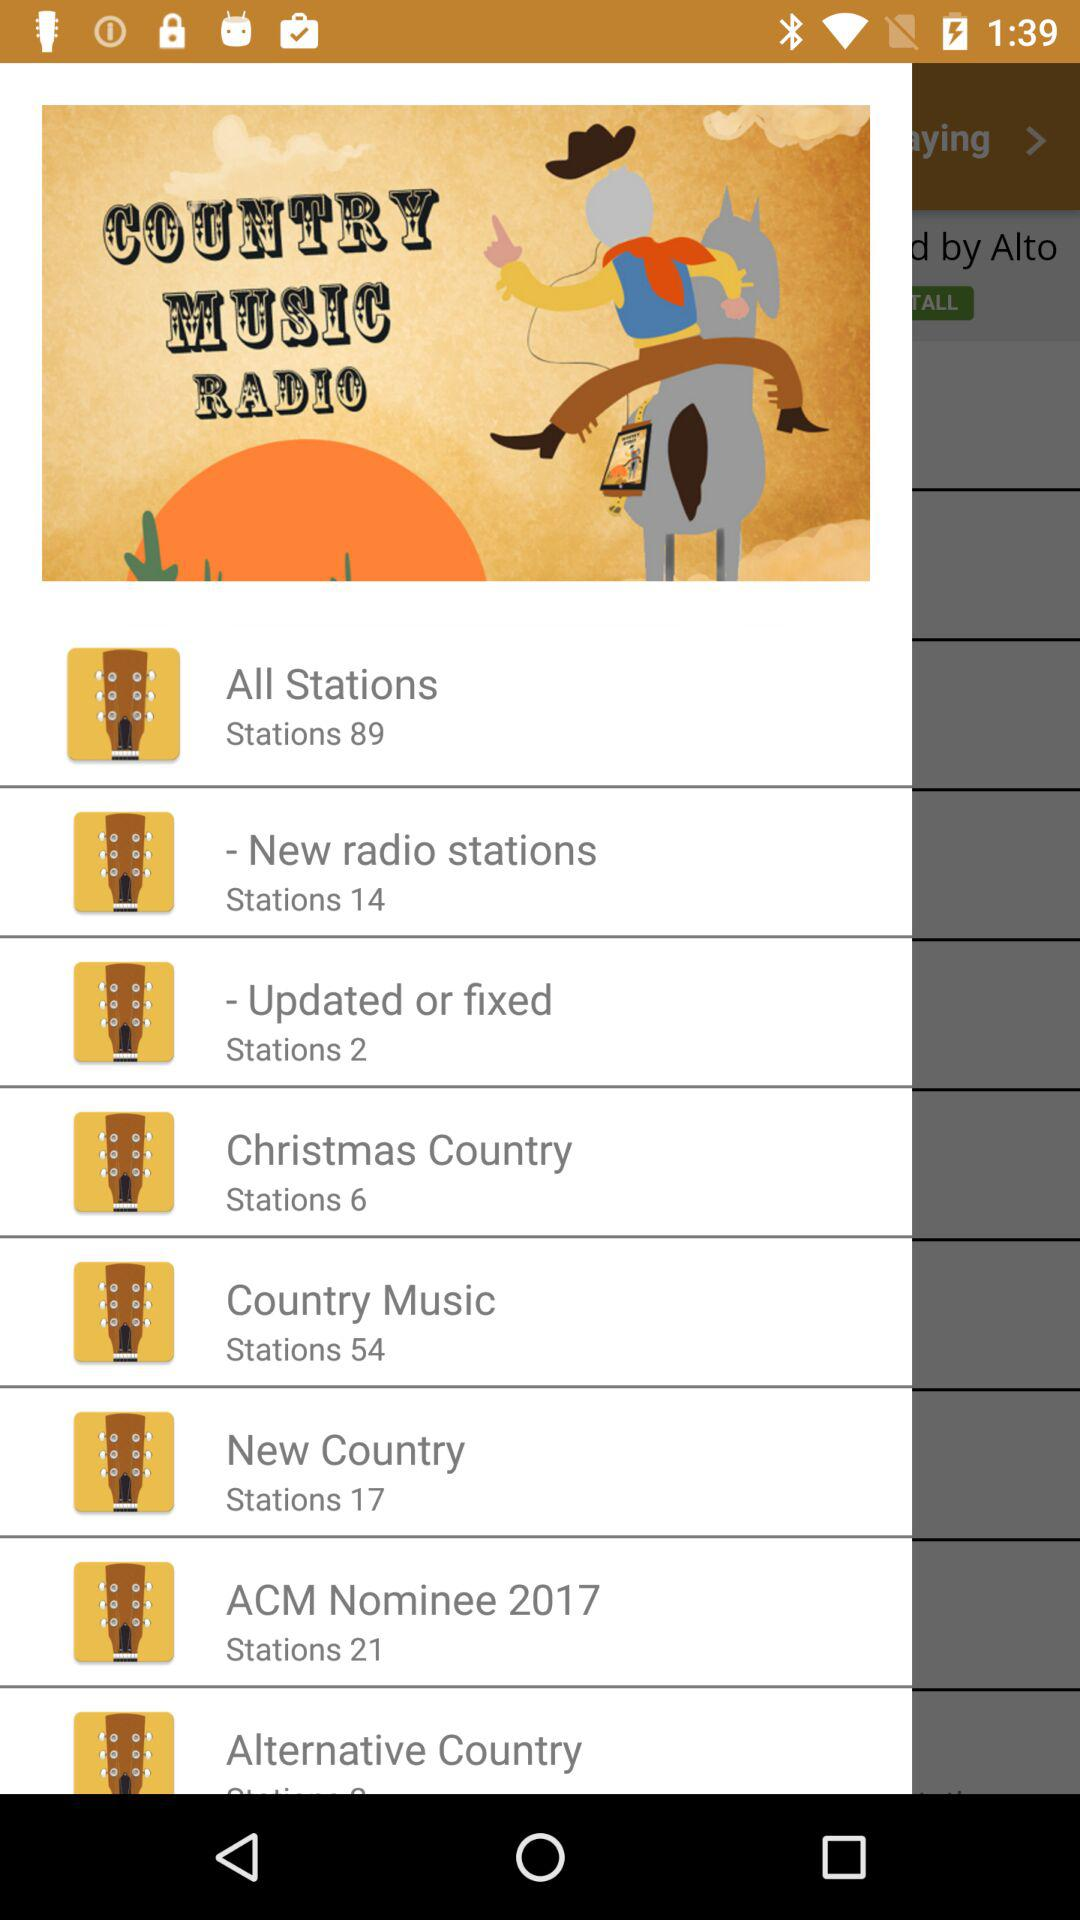How many stations are there in "Christmas Country"? There are 6 stations in "Christmas Country". 